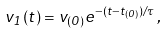Convert formula to latex. <formula><loc_0><loc_0><loc_500><loc_500>v _ { 1 } ( t ) = v _ { ( 0 ) } e ^ { - ( t - t _ { ( 0 ) } ) / \tau } \, ,</formula> 